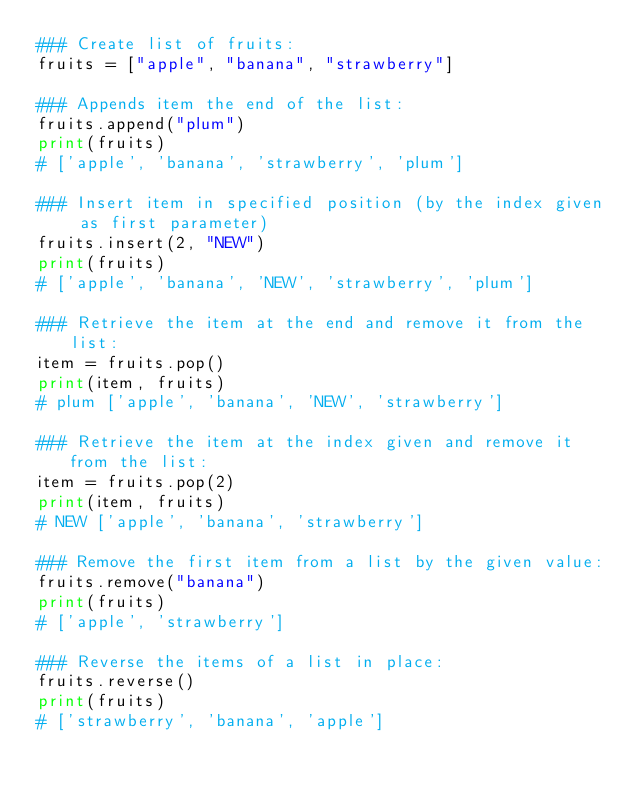Convert code to text. <code><loc_0><loc_0><loc_500><loc_500><_Python_>### Create list of fruits:
fruits = ["apple", "banana", "strawberry"]

### Appends item the end of the list:
fruits.append("plum")
print(fruits)
# ['apple', 'banana', 'strawberry', 'plum']

### Insert item in specified position (by the index given as first parameter) 
fruits.insert(2, "NEW")
print(fruits)
# ['apple', 'banana', 'NEW', 'strawberry', 'plum']

### Retrieve the item at the end and remove it from the list:
item = fruits.pop() 
print(item, fruits)
# plum ['apple', 'banana', 'NEW', 'strawberry']

### Retrieve the item at the index given and remove it from the list:
item = fruits.pop(2)
print(item, fruits)
# NEW ['apple', 'banana', 'strawberry']

### Remove the first item from a list by the given value:
fruits.remove("banana")
print(fruits)
# ['apple', 'strawberry']

### Reverse the items of a list in place:
fruits.reverse()
print(fruits)
# ['strawberry', 'banana', 'apple']
</code> 